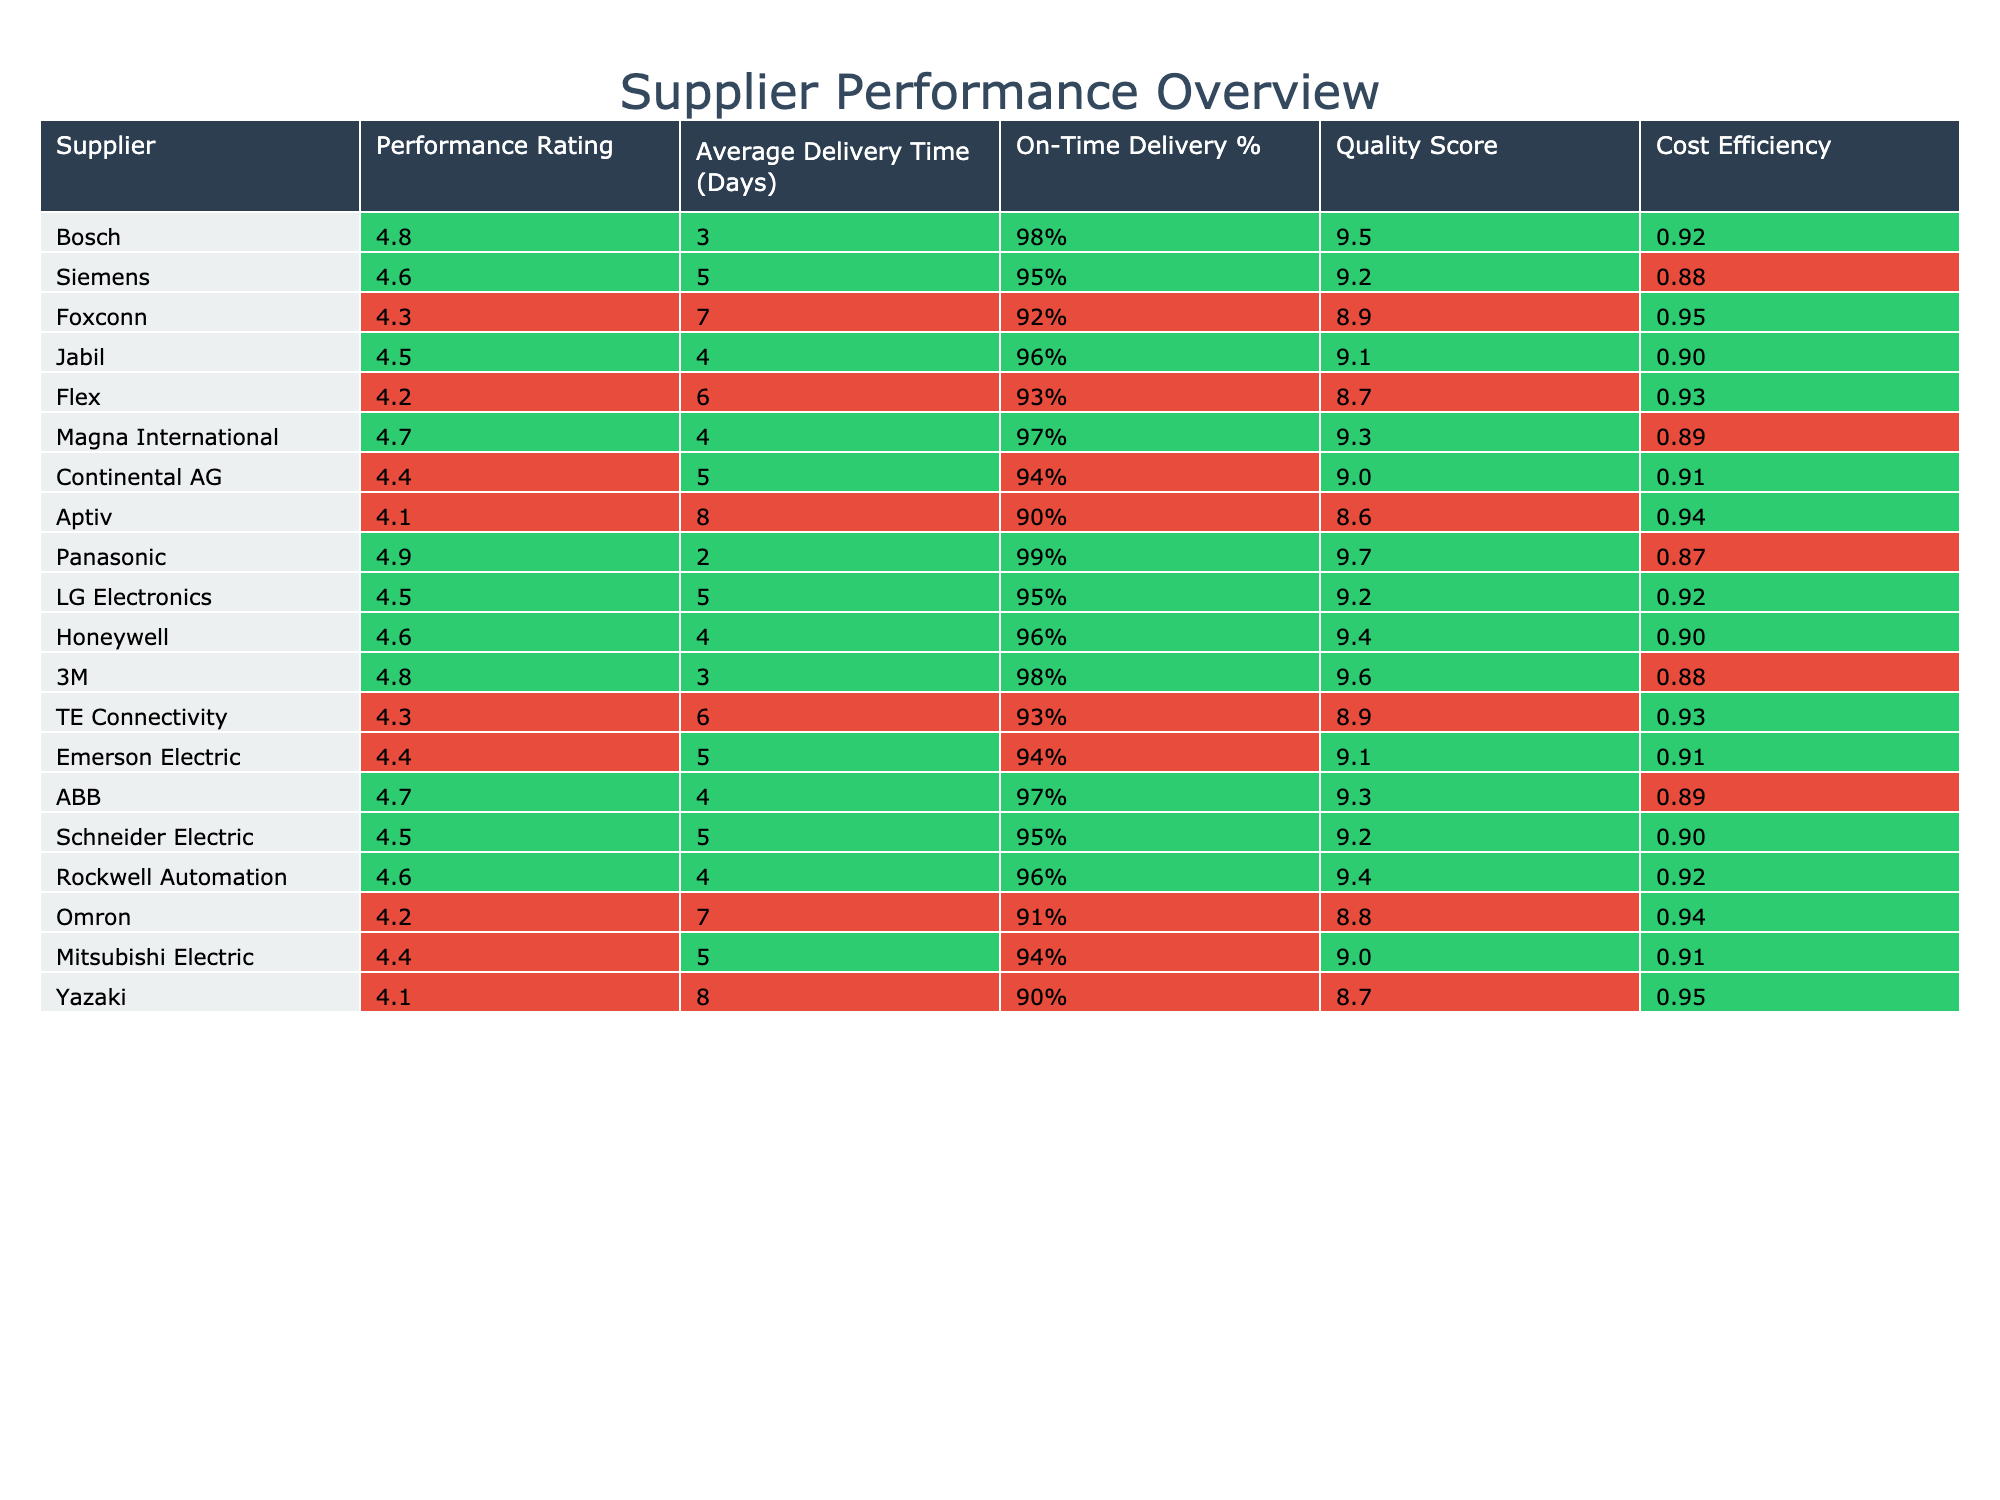What is the highest performance rating among the suppliers? The performance ratings listed in the table go up to a maximum of 4.9, which is the rating given to Panasonic.
Answer: 4.9 Which supplier has the average delivery time of 7 days? By reviewing the table, Aptiv and Omron both have an average delivery time of 8 days, while Foxconn and Flex have 7 and 6 respectively. Therefore, Foxconn is the only supplier with an average delivery time of 7 days.
Answer: Foxconn What is the On-Time Delivery percentage for the supplier with the Performance Rating of 4.1? The table indicates that both Aptiv and Yazaki have a Performance Rating of 4.1. Looking at the On-Time Delivery percentage for both, Aptiv has 90% and Yazaki also has 90%. Hence, both have the same On-Time Delivery percentage.
Answer: 90% Which supplier has the best combination of quality score and cost efficiency? To find the best combination, we compare Quality Score and Cost Efficiency for each supplier. The highest Quality Score is 9.7 for Panasonic, but its Cost Efficiency is 0.87, which is lower than others like Bosch, with a Quality Score of 9.5 and Cost Efficiency of 0.92. On comparison, Bosch has the best combination of high Quality Score and Cost Efficient value.
Answer: Bosch Is there any supplier with a performance rating below 4.2? Looking through the table, both Foxconn and Aptiv have performance ratings of 4.3 and 4.1 respectively. Since Aptiv scored 4.1, the answer to the question is yes.
Answer: Yes Calculate the average delivery time of the three highest-performing suppliers. The three suppliers with the highest performance ratings are Panasonic (2 days), Bosch (3 days), and 3M (3 days). Adding these delivery times gives a total of 8 days. Dividing by 3 suppliers results in an average delivery time of approximately 2.67 days.
Answer: 2.67 days Which supplier has the highest Quality Score and what is it? From the table, Panasonic has the highest Quality Score of 9.7, as indicated in the fourth column.
Answer: 9.7 What is the average Performance Rating of all suppliers? To calculate the average Performance Rating, we sum all the ratings provided and divide by the total number of suppliers (which is 20). The total of the ratings is 88.6, and dividing this by 20 results in an average of 4.43.
Answer: 4.43 Identify a supplier that has both a delivery time lower than 5 days and an On-Time Delivery percentage above 95%. From the table, Bosch (3 days, 98%) and Panasonic (2 days, 99%) meet this condition. Therefore, both Bosch and Panasonic are valid answers.
Answer: Bosch and Panasonic How many suppliers have a cost efficiency of 0.90 or higher? By reviewing the Cost Efficiency values, we see that the suppliers with 0.90 or higher are Bosch, 3M, Honeywell, and Schneider Electric. This makes for a total of 6 suppliers meeting this criterion.
Answer: 6 suppliers Which supplier has the lowest score in both Quality Score and Cost Efficiency? In the table, Aptiv has the lowest Quality Score of 8.6 and a Cost Efficiency of 0.94. Therefore, Aptiv holds the lowest score for both criteria among the listed suppliers.
Answer: Aptiv 